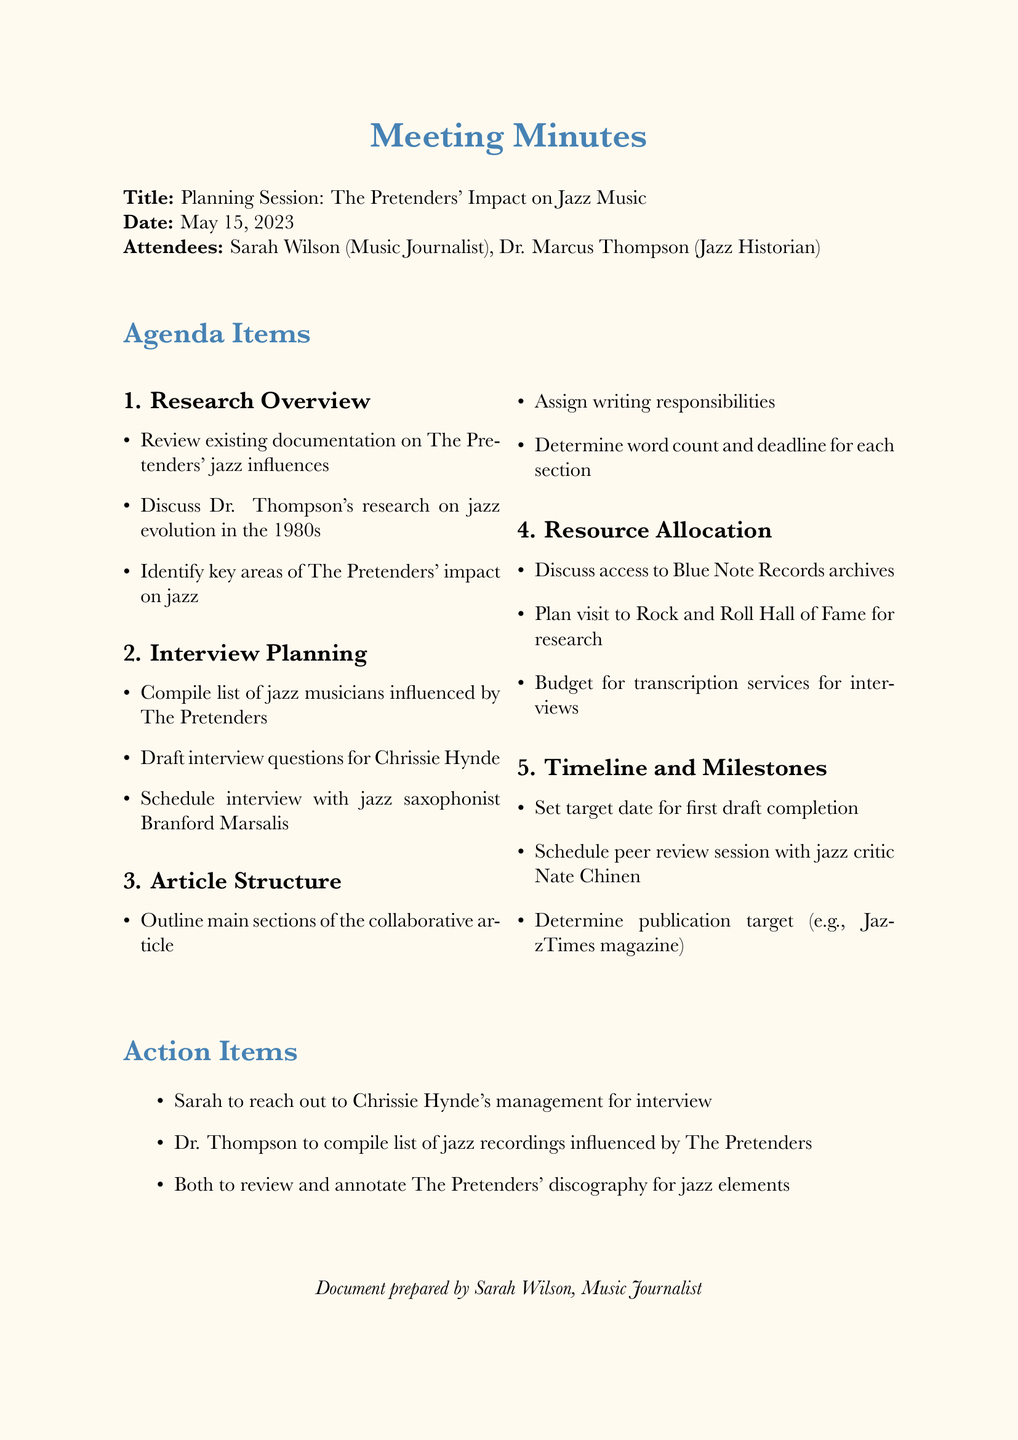What is the meeting title? The meeting title is explicitly stated in the document, which is "Planning Session: The Pretenders' Impact on Jazz Music."
Answer: Planning Session: The Pretenders' Impact on Jazz Music Who attended the meeting? The document lists the attendees, which include Sarah Wilson and Dr. Marcus Thompson.
Answer: Sarah Wilson, Dr. Marcus Thompson What is the date of the meeting? The date is specifically mentioned in the document as May 15, 2023.
Answer: May 15, 2023 What is one of the agenda items discussed? The document includes several agenda items; one example is "Research Overview."
Answer: Research Overview Who is responsible for reaching out to Chrissie Hynde's management? The action items section specifies that Sarah is responsible for this task.
Answer: Sarah What is the target publication for the article? The document mentions "JazzTimes magazine" as the target publication for the article.
Answer: JazzTimes magazine What are the two attendees' professions? Their professions are stated next to their names: Sarah is a Music Journalist and Dr. Thompson is a Jazz Historian.
Answer: Music Journalist, Jazz Historian How many main agenda topics were discussed? The agenda contains a total of five main topics, as listed in the document.
Answer: Five What is planned for the first draft? The timeline includes a specific target date for completing the first draft, which is set during the meeting.
Answer: Target date for first draft completion 